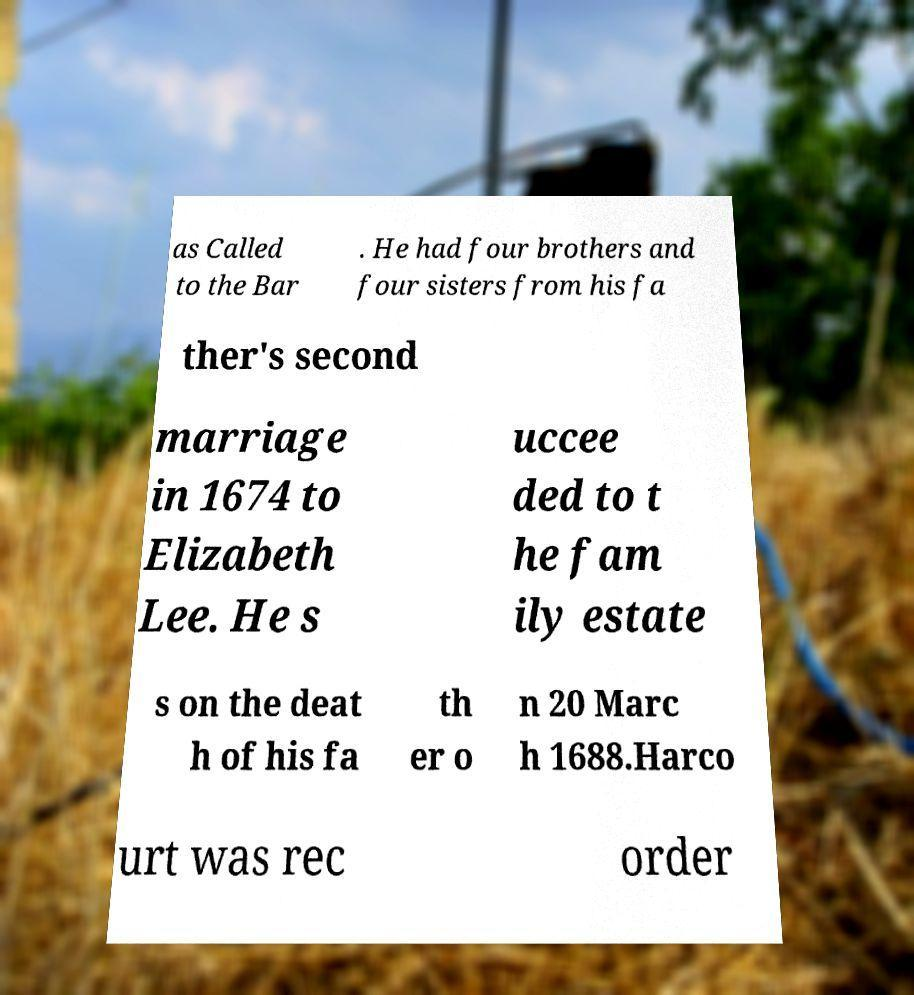Please identify and transcribe the text found in this image. as Called to the Bar . He had four brothers and four sisters from his fa ther's second marriage in 1674 to Elizabeth Lee. He s uccee ded to t he fam ily estate s on the deat h of his fa th er o n 20 Marc h 1688.Harco urt was rec order 